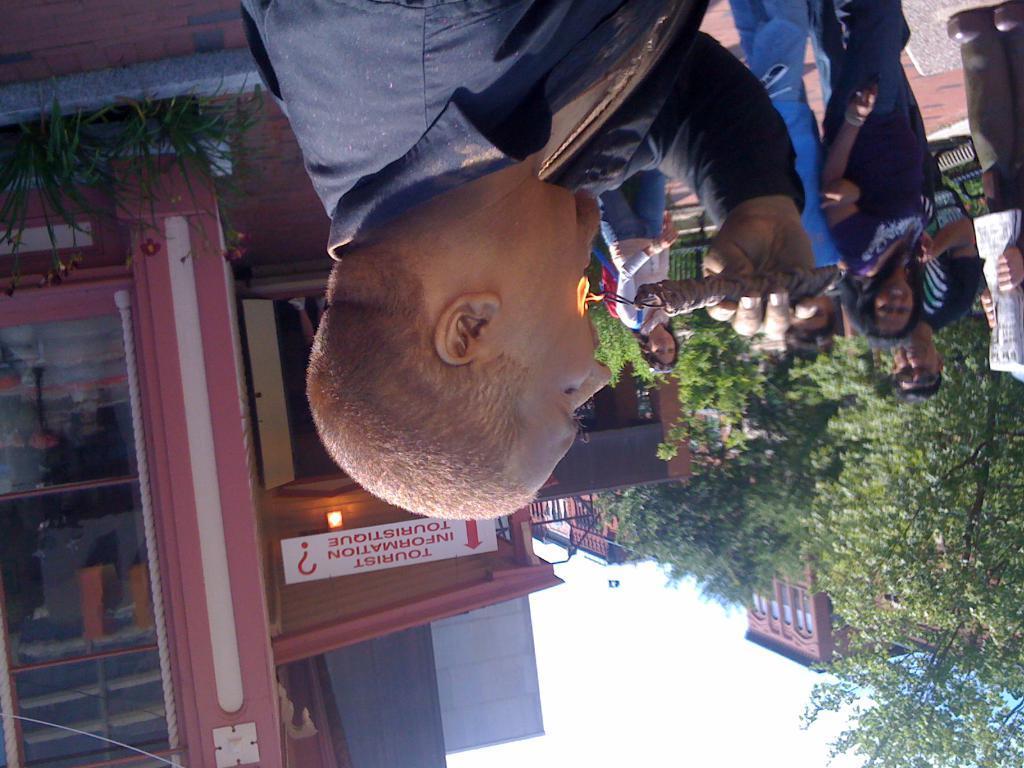Describe this image in one or two sentences. In this image I can see the group of people standing and wearing the different color dresses. I can see one person is holding the wire with fire. In the background I can see building, trees and the white sky. I can see a board to the building. 